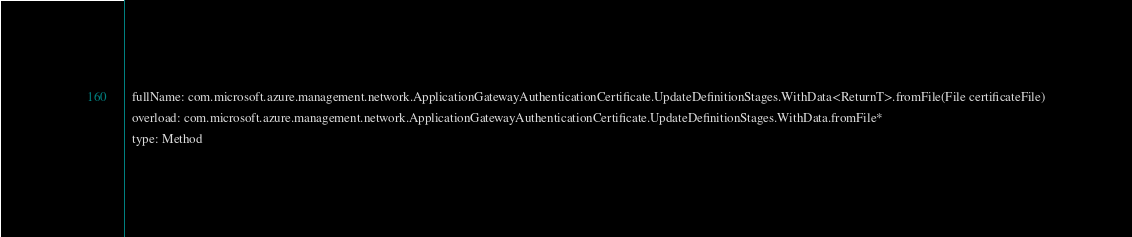<code> <loc_0><loc_0><loc_500><loc_500><_YAML_>  fullName: com.microsoft.azure.management.network.ApplicationGatewayAuthenticationCertificate.UpdateDefinitionStages.WithData<ReturnT>.fromFile(File certificateFile)
  overload: com.microsoft.azure.management.network.ApplicationGatewayAuthenticationCertificate.UpdateDefinitionStages.WithData.fromFile*
  type: Method</code> 